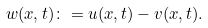Convert formula to latex. <formula><loc_0><loc_0><loc_500><loc_500>w ( x , t ) \colon = u ( x , t ) - v ( x , t ) .</formula> 